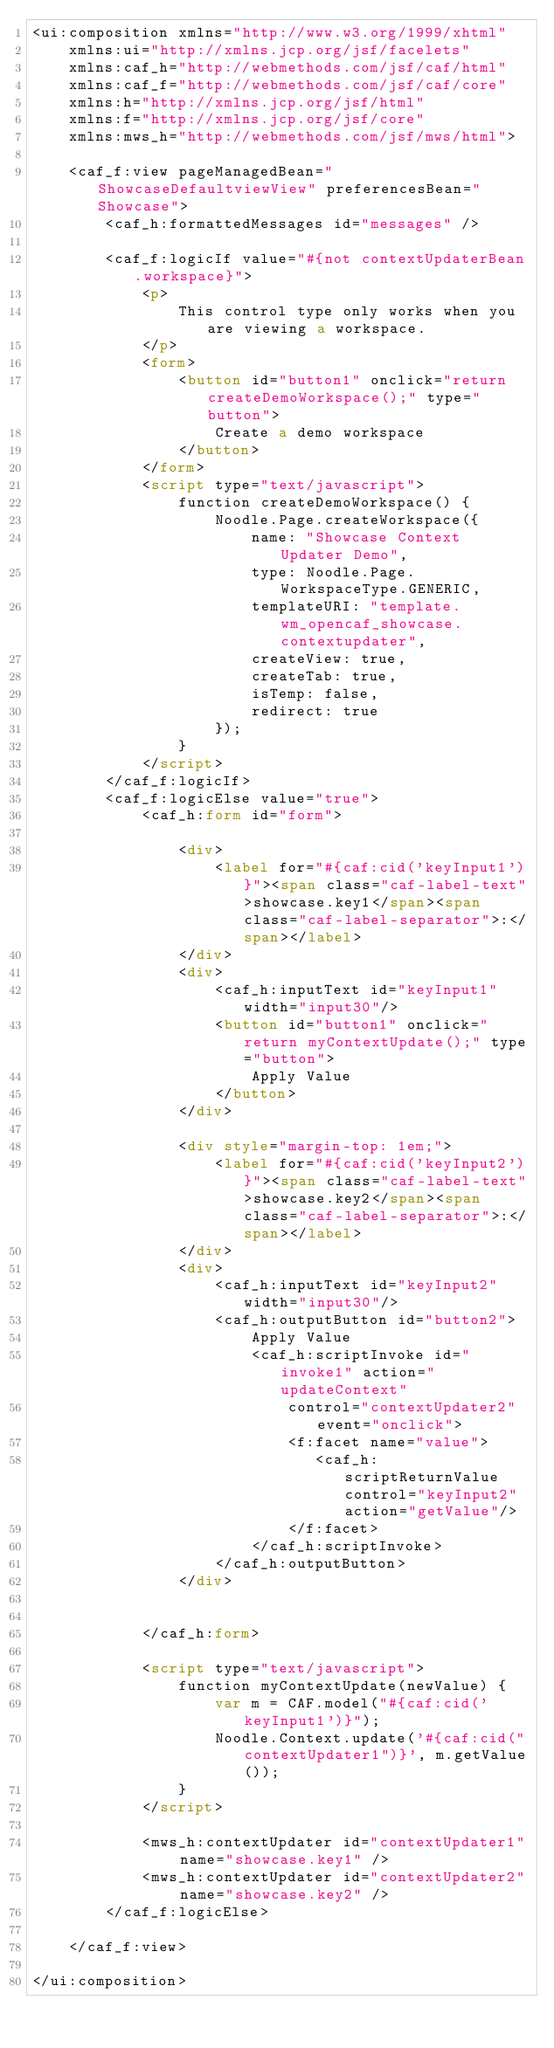<code> <loc_0><loc_0><loc_500><loc_500><_HTML_><ui:composition xmlns="http://www.w3.org/1999/xhtml"
    xmlns:ui="http://xmlns.jcp.org/jsf/facelets"
    xmlns:caf_h="http://webmethods.com/jsf/caf/html"
    xmlns:caf_f="http://webmethods.com/jsf/caf/core"
    xmlns:h="http://xmlns.jcp.org/jsf/html"
    xmlns:f="http://xmlns.jcp.org/jsf/core"
    xmlns:mws_h="http://webmethods.com/jsf/mws/html">

    <caf_f:view pageManagedBean="ShowcaseDefaultviewView" preferencesBean="Showcase">
        <caf_h:formattedMessages id="messages" />

        <caf_f:logicIf value="#{not contextUpdaterBean.workspace}">
            <p>
                This control type only works when you are viewing a workspace.                
            </p>
            <form>
	            <button id="button1" onclick="return createDemoWorkspace();" type="button">
	                Create a demo workspace
	            </button>
            </form>
	        <script type="text/javascript">
	            function createDemoWorkspace() {  
	                Noodle.Page.createWorkspace({
	                    name: "Showcase Context Updater Demo",
	                    type: Noodle.Page.WorkspaceType.GENERIC,
	                    templateURI: "template.wm_opencaf_showcase.contextupdater",
	                    createView: true,
	                    createTab: true,
	                    isTemp: false,
	                    redirect: true
	                });
	            }           
	        </script>
        </caf_f:logicIf>
        <caf_f:logicElse value="true">
	        <caf_h:form id="form">
	            
	            <div>
	                <label for="#{caf:cid('keyInput1')}"><span class="caf-label-text">showcase.key1</span><span class="caf-label-separator">:</span></label>
	            </div>
	            <div>
	                <caf_h:inputText id="keyInput1" width="input30"/>
	                <button id="button1" onclick="return myContextUpdate();" type="button">
	                    Apply Value
	                </button>
	            </div>
	
	            <div style="margin-top: 1em;">
	                <label for="#{caf:cid('keyInput2')}"><span class="caf-label-text">showcase.key2</span><span class="caf-label-separator">:</span></label>
	            </div>
	            <div>
	                <caf_h:inputText id="keyInput2" width="input30"/>
	                <caf_h:outputButton id="button2">
	                    Apply Value
	                    <caf_h:scriptInvoke id="invoke1" action="updateContext" 
	                        control="contextUpdater2" event="onclick">
	                        <f:facet name="value">
	                           <caf_h:scriptReturnValue control="keyInput2" action="getValue"/>
	                        </f:facet>
	                    </caf_h:scriptInvoke> 
	                </caf_h:outputButton>
	            </div>
	
	
	        </caf_h:form>
	
	        <script type="text/javascript">
	            function myContextUpdate(newValue) {
	                var m = CAF.model("#{caf:cid('keyInput1')}");
	                Noodle.Context.update('#{caf:cid("contextUpdater1")}', m.getValue());
	            }
	        </script>

	        <mws_h:contextUpdater id="contextUpdater1" name="showcase.key1" />
            <mws_h:contextUpdater id="contextUpdater2" name="showcase.key2" />
        </caf_f:logicElse>

    </caf_f:view>

</ui:composition></code> 